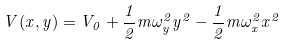Convert formula to latex. <formula><loc_0><loc_0><loc_500><loc_500>V ( x , y ) = V _ { 0 } + \frac { 1 } { 2 } m \omega _ { y } ^ { 2 } y ^ { 2 } - \frac { 1 } { 2 } m \omega _ { x } ^ { 2 } x ^ { 2 }</formula> 